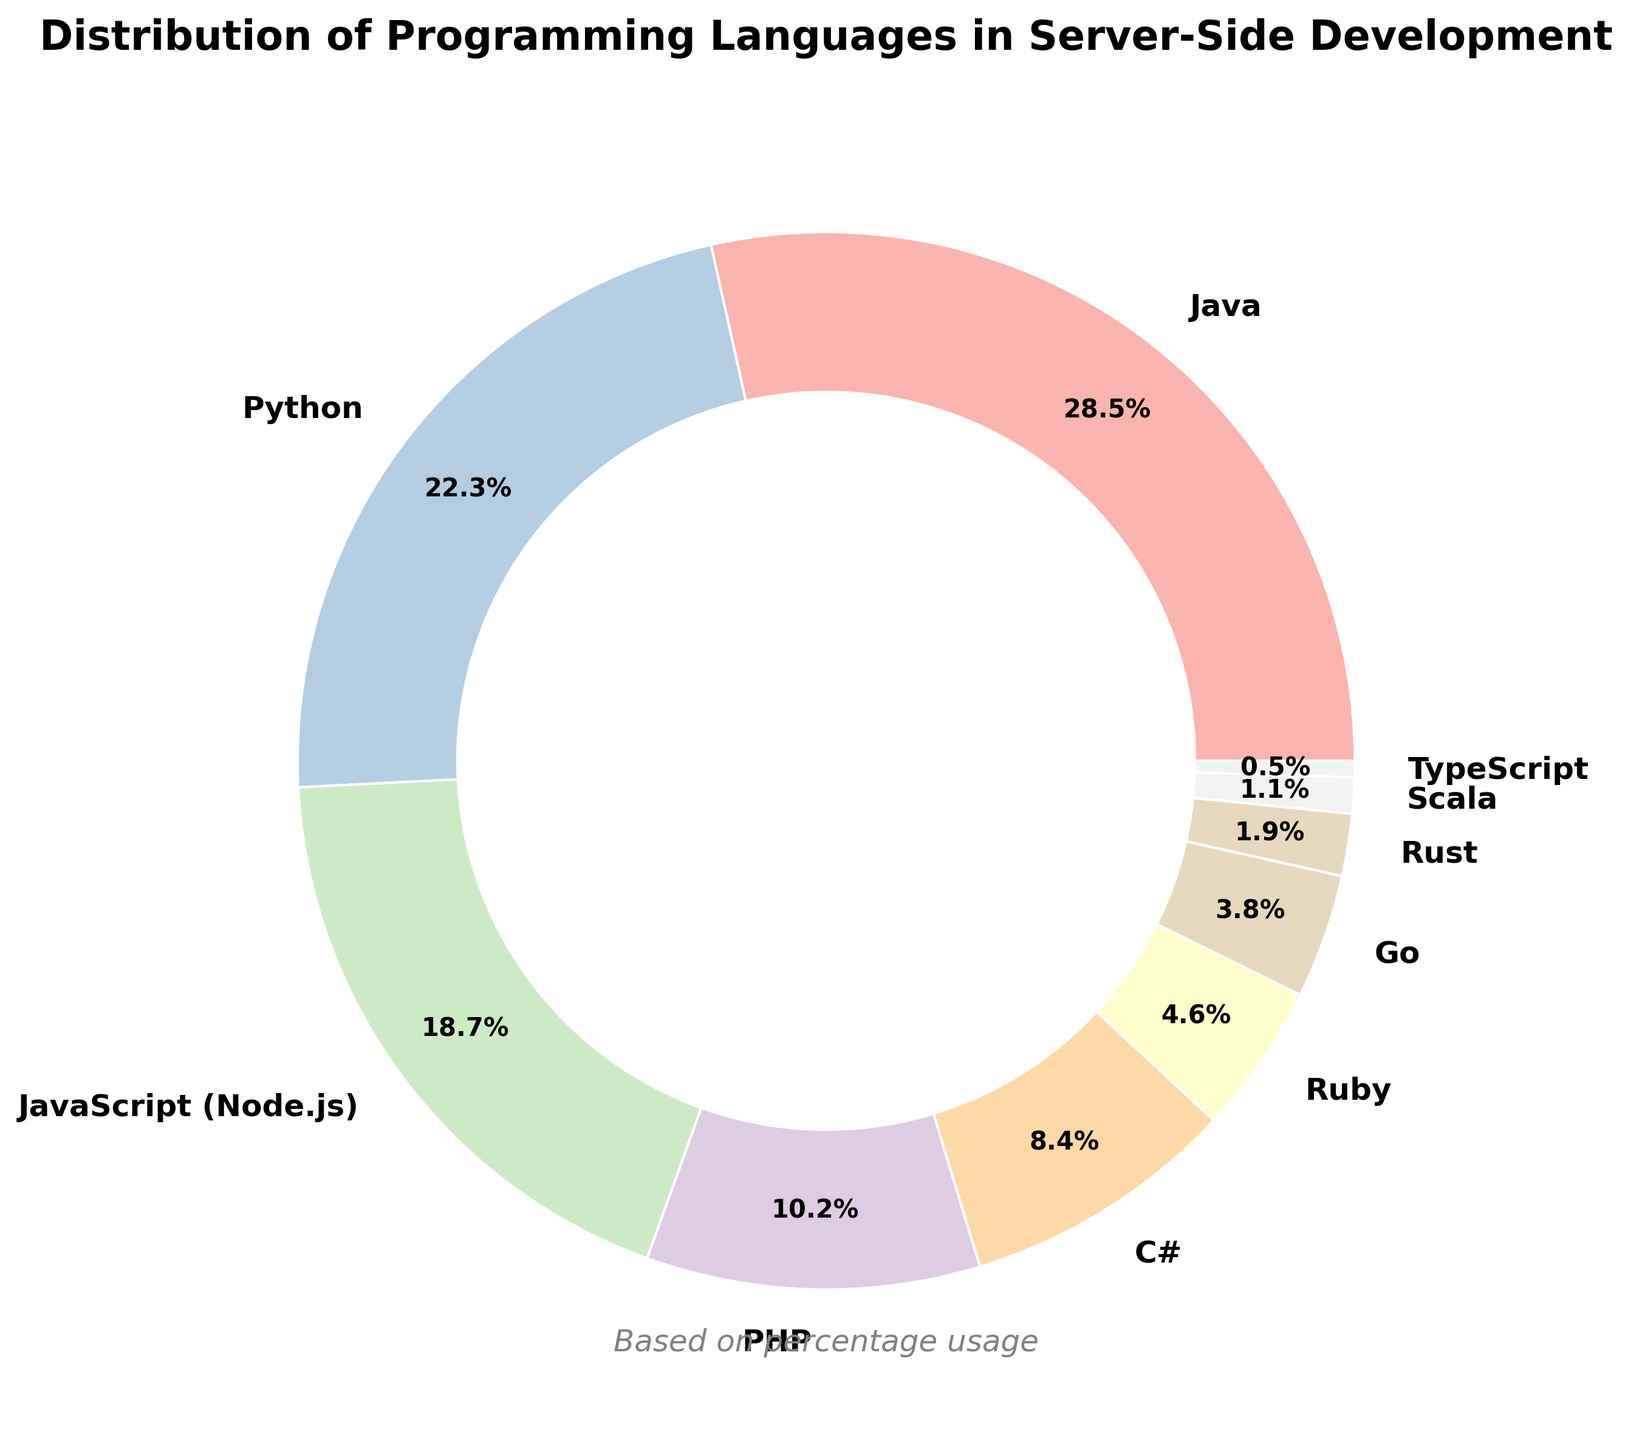How many programming languages have a usage percentage greater than 20%? Refer to the pie chart and identify programming languages with percentages greater than 20%. Java (28.5%) and Python (22.3%) are the only languages that exceed this threshold, so there are 2 languages.
Answer: 2 Which programming language has the highest percentage usage in server-side development? Look at the wedges in the pie chart and observe the labels and their corresponding percentages. Java has the highest percentage at 28.5%.
Answer: Java What is the combined usage percentage of PHP and C#? Identify the percentages from the pie chart: PHP (10.2%) and C# (8.4%). Sum these percentages: 10.2% + 8.4% = 18.6%.
Answer: 18.6% What is the difference in usage percentage between Python and JavaScript (Node.js)? Locate the percentages for Python (22.3%) and JavaScript (Node.js) (18.7%). Subtract the lower value from the higher: 22.3% - 18.7% = 3.6%.
Answer: 3.6% Which programming languages have a usage percentage less than 5%? Inspect the pie chart and find languages with percentages below 5%. These languages are Ruby (4.6%), Go (3.8%), Rust (1.9%), Scala (1.1%), and TypeScript (0.5%).
Answer: Ruby, Go, Rust, Scala, TypeScript What is the ratio of the usage of Python to PHP in server-side development? Get the percentages from the chart: Python (22.3%) and PHP (10.2%). Calculate the ratio by dividing the higher value by the lower value: 22.3 / 10.2 ≈ 2.19.
Answer: ~2.19 If you combine Java, Python, and JavaScript (Node.js), what percentage of server-side development do they cover? Add the percentages of Java (28.5%), Python (22.3%), and JavaScript (Node.js) (18.7%) from the chart: 28.5% + 22.3% + 18.7% = 69.5%.
Answer: 69.5% What percentage of server-side development is not covered by the top three programming languages? Calculate the coverage of the top three languages: Java (28.5%), Python (22.3%), and JavaScript (Node.js) (18.7%). Sum them: 28.5% + 22.3% + 18.7% = 69.5%. Subtract this from 100% to get the remaining percentage: 100% - 69.5% = 30.5%.
Answer: 30.5% Which programming language has the smallest wedge in the pie chart? Look for the programming language with the lowest percentage. TypeScript is the language with the smallest wedge at 0.5%.
Answer: TypeScript 